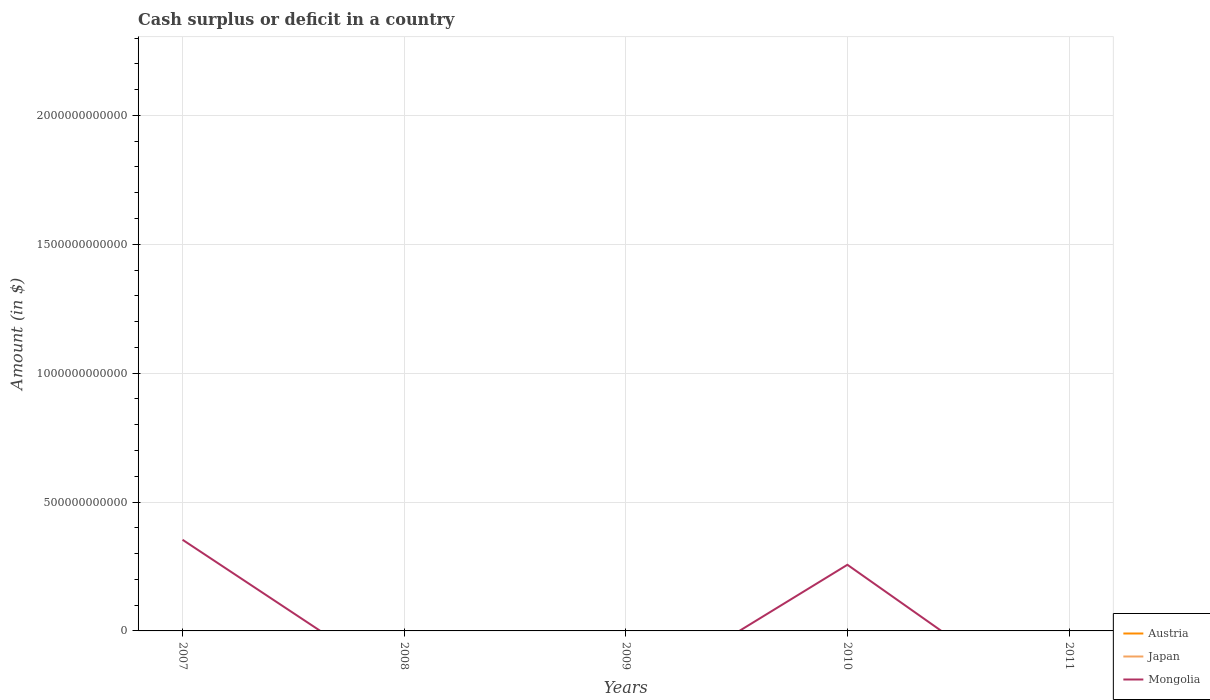What is the total amount of cash surplus or deficit in Mongolia in the graph?
Keep it short and to the point. 9.71e+1. What is the difference between the highest and the second highest amount of cash surplus or deficit in Mongolia?
Offer a very short reply. 3.54e+11. What is the difference between the highest and the lowest amount of cash surplus or deficit in Japan?
Your answer should be compact. 0. How many lines are there?
Keep it short and to the point. 1. How many years are there in the graph?
Make the answer very short. 5. What is the difference between two consecutive major ticks on the Y-axis?
Give a very brief answer. 5.00e+11. Does the graph contain any zero values?
Give a very brief answer. Yes. How are the legend labels stacked?
Keep it short and to the point. Vertical. What is the title of the graph?
Give a very brief answer. Cash surplus or deficit in a country. Does "Bulgaria" appear as one of the legend labels in the graph?
Give a very brief answer. No. What is the label or title of the Y-axis?
Your answer should be compact. Amount (in $). What is the Amount (in $) of Japan in 2007?
Offer a terse response. 0. What is the Amount (in $) of Mongolia in 2007?
Offer a very short reply. 3.54e+11. What is the Amount (in $) in Japan in 2008?
Ensure brevity in your answer.  0. What is the Amount (in $) of Mongolia in 2008?
Ensure brevity in your answer.  0. What is the Amount (in $) in Austria in 2010?
Your response must be concise. 0. What is the Amount (in $) of Japan in 2010?
Make the answer very short. 0. What is the Amount (in $) of Mongolia in 2010?
Your answer should be very brief. 2.57e+11. Across all years, what is the maximum Amount (in $) in Mongolia?
Offer a very short reply. 3.54e+11. Across all years, what is the minimum Amount (in $) in Mongolia?
Your answer should be compact. 0. What is the total Amount (in $) in Mongolia in the graph?
Your answer should be very brief. 6.10e+11. What is the difference between the Amount (in $) of Mongolia in 2007 and that in 2010?
Your answer should be very brief. 9.71e+1. What is the average Amount (in $) in Austria per year?
Your response must be concise. 0. What is the average Amount (in $) in Mongolia per year?
Keep it short and to the point. 1.22e+11. What is the ratio of the Amount (in $) of Mongolia in 2007 to that in 2010?
Give a very brief answer. 1.38. What is the difference between the highest and the lowest Amount (in $) of Mongolia?
Make the answer very short. 3.54e+11. 